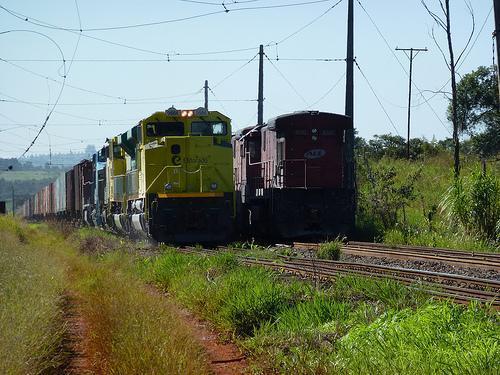How many trains are there?
Give a very brief answer. 2. 